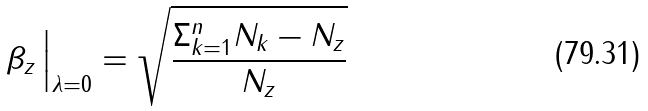Convert formula to latex. <formula><loc_0><loc_0><loc_500><loc_500>\beta _ { z } \, \Big | _ { \lambda = 0 } = \sqrt { \frac { \Sigma _ { k = 1 } ^ { n } N _ { k } - N _ { z } } { N _ { z } } }</formula> 